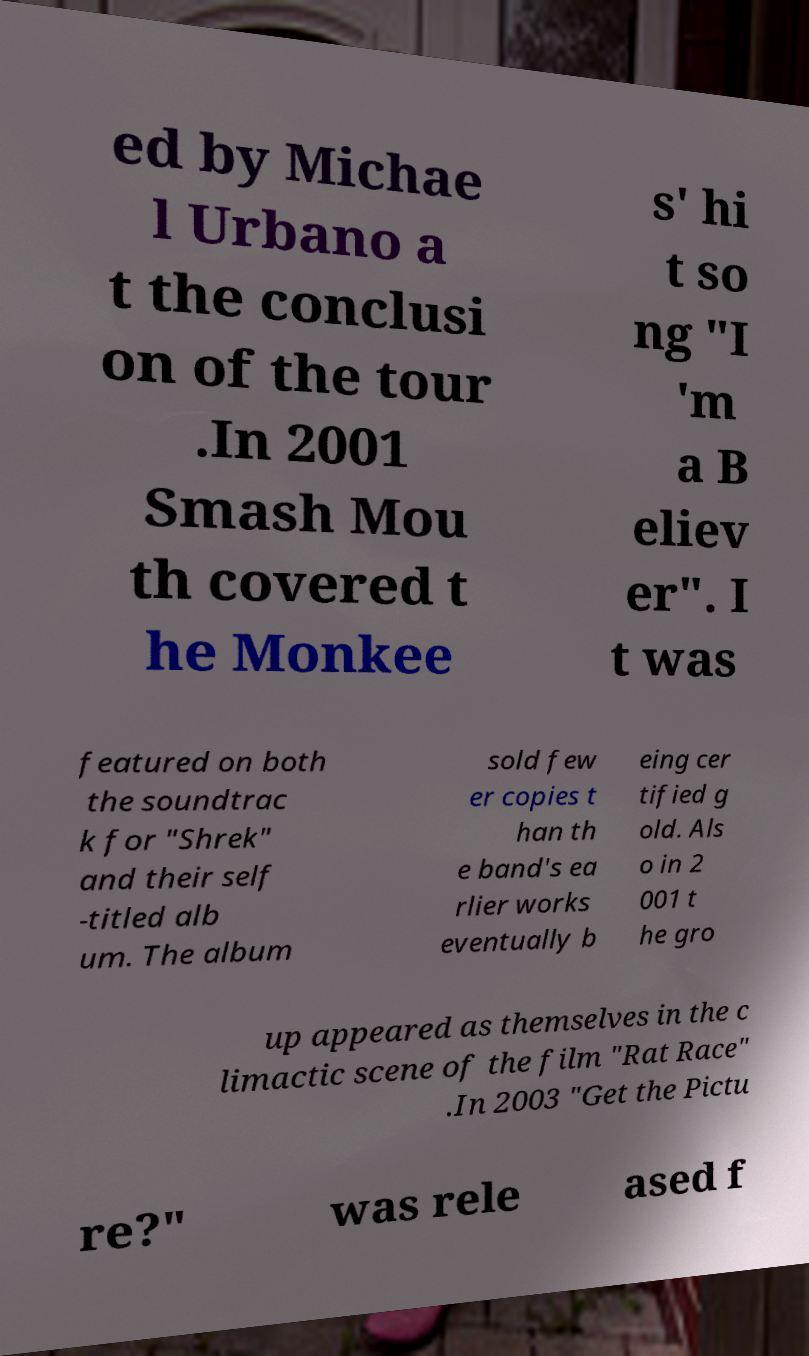Can you read and provide the text displayed in the image?This photo seems to have some interesting text. Can you extract and type it out for me? ed by Michae l Urbano a t the conclusi on of the tour .In 2001 Smash Mou th covered t he Monkee s' hi t so ng "I 'm a B eliev er". I t was featured on both the soundtrac k for "Shrek" and their self -titled alb um. The album sold few er copies t han th e band's ea rlier works eventually b eing cer tified g old. Als o in 2 001 t he gro up appeared as themselves in the c limactic scene of the film "Rat Race" .In 2003 "Get the Pictu re?" was rele ased f 